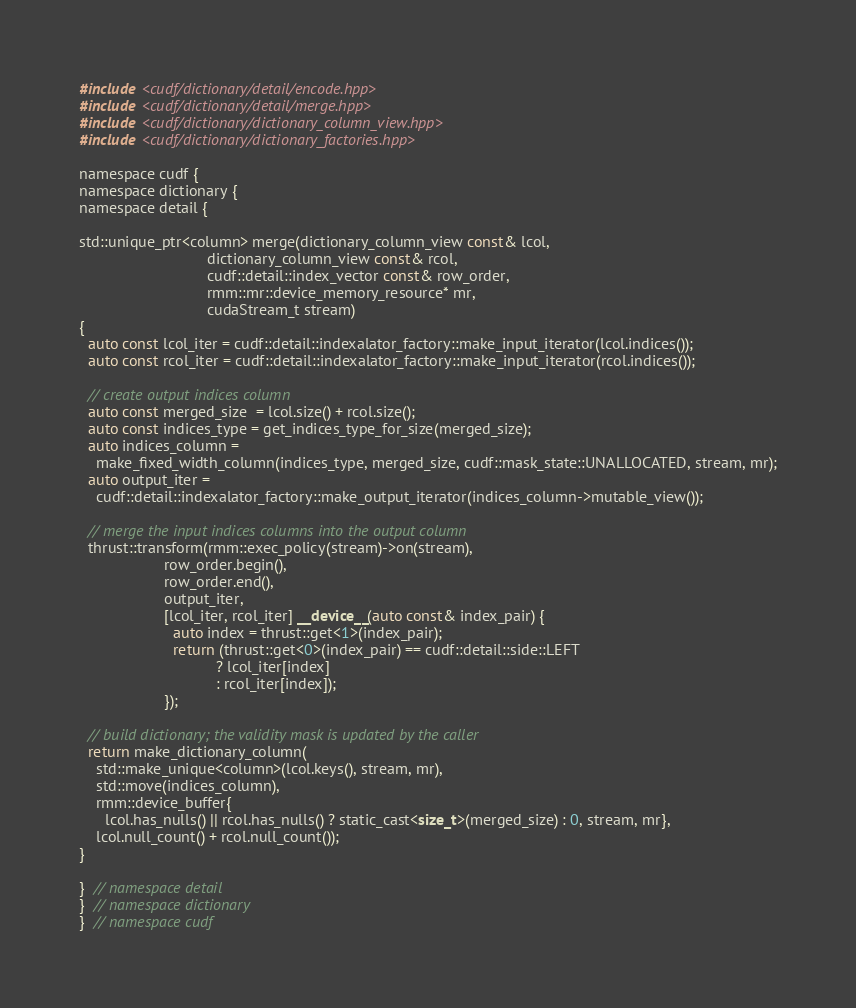Convert code to text. <code><loc_0><loc_0><loc_500><loc_500><_Cuda_>#include <cudf/dictionary/detail/encode.hpp>
#include <cudf/dictionary/detail/merge.hpp>
#include <cudf/dictionary/dictionary_column_view.hpp>
#include <cudf/dictionary/dictionary_factories.hpp>

namespace cudf {
namespace dictionary {
namespace detail {

std::unique_ptr<column> merge(dictionary_column_view const& lcol,
                              dictionary_column_view const& rcol,
                              cudf::detail::index_vector const& row_order,
                              rmm::mr::device_memory_resource* mr,
                              cudaStream_t stream)
{
  auto const lcol_iter = cudf::detail::indexalator_factory::make_input_iterator(lcol.indices());
  auto const rcol_iter = cudf::detail::indexalator_factory::make_input_iterator(rcol.indices());

  // create output indices column
  auto const merged_size  = lcol.size() + rcol.size();
  auto const indices_type = get_indices_type_for_size(merged_size);
  auto indices_column =
    make_fixed_width_column(indices_type, merged_size, cudf::mask_state::UNALLOCATED, stream, mr);
  auto output_iter =
    cudf::detail::indexalator_factory::make_output_iterator(indices_column->mutable_view());

  // merge the input indices columns into the output column
  thrust::transform(rmm::exec_policy(stream)->on(stream),
                    row_order.begin(),
                    row_order.end(),
                    output_iter,
                    [lcol_iter, rcol_iter] __device__(auto const& index_pair) {
                      auto index = thrust::get<1>(index_pair);
                      return (thrust::get<0>(index_pair) == cudf::detail::side::LEFT
                                ? lcol_iter[index]
                                : rcol_iter[index]);
                    });

  // build dictionary; the validity mask is updated by the caller
  return make_dictionary_column(
    std::make_unique<column>(lcol.keys(), stream, mr),
    std::move(indices_column),
    rmm::device_buffer{
      lcol.has_nulls() || rcol.has_nulls() ? static_cast<size_t>(merged_size) : 0, stream, mr},
    lcol.null_count() + rcol.null_count());
}

}  // namespace detail
}  // namespace dictionary
}  // namespace cudf
</code> 